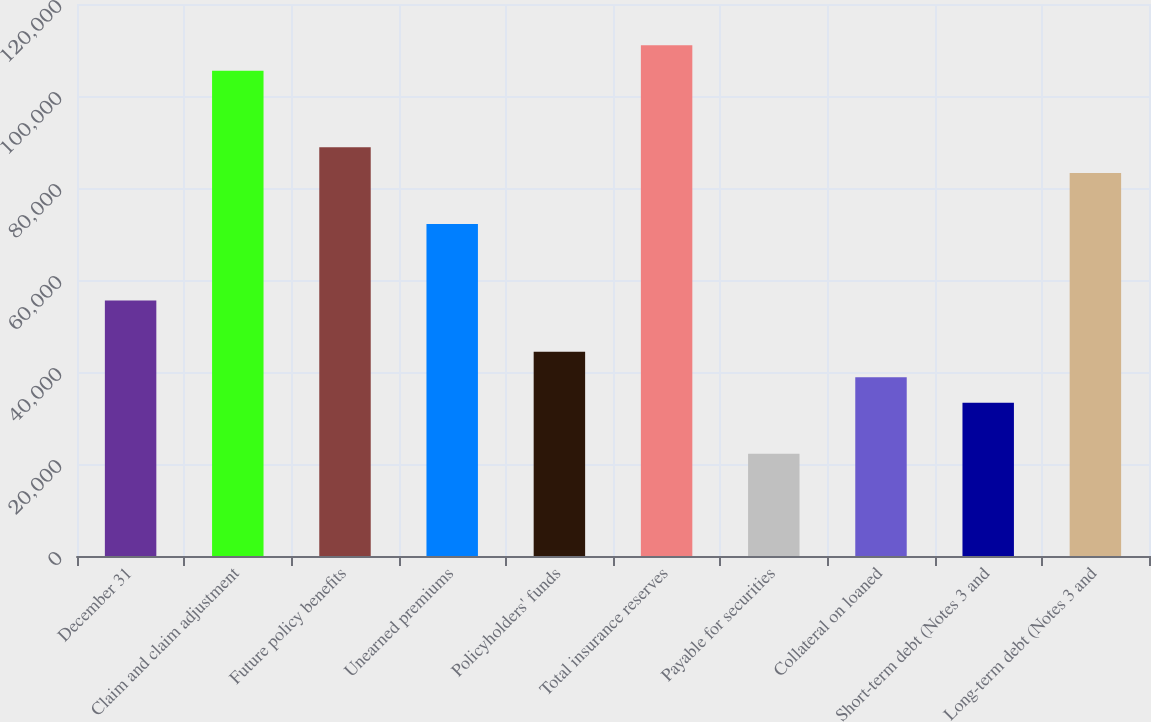Convert chart to OTSL. <chart><loc_0><loc_0><loc_500><loc_500><bar_chart><fcel>December 31<fcel>Claim and claim adjustment<fcel>Future policy benefits<fcel>Unearned premiums<fcel>Policyholders' funds<fcel>Total insurance reserves<fcel>Payable for securities<fcel>Collateral on loaned<fcel>Short-term debt (Notes 3 and<fcel>Long-term debt (Notes 3 and<nl><fcel>55524.6<fcel>105496<fcel>88838.9<fcel>72181.7<fcel>44419.8<fcel>111048<fcel>22210.3<fcel>38867.5<fcel>33315.1<fcel>83286.5<nl></chart> 